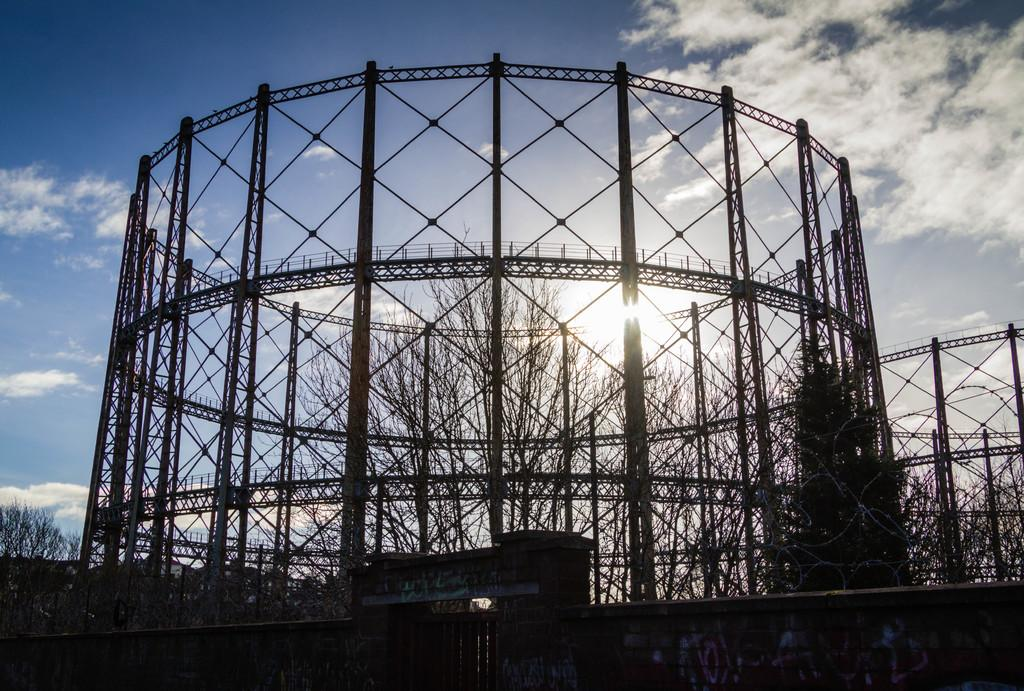What can be seen in the sky in the image? The sky is visible in the image, but no specific details about the sky are mentioned. What type of structure is in the image? There is a fence in the image. What type of vegetation is present in the image? Trees are present in the image. How would you describe the lighting in the image? The image is described as dark. What type of circle is present in the image? There is no mention of a circle in the image, so it cannot be determined if one is present. 